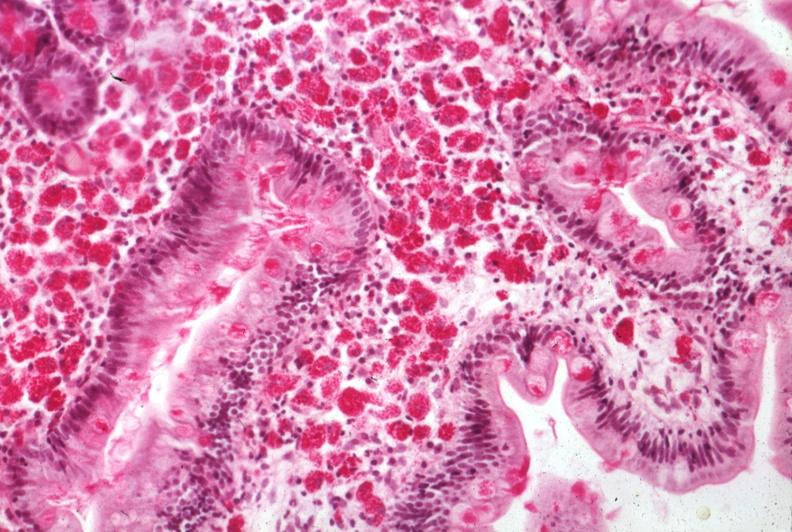what is present?
Answer the question using a single word or phrase. Gastrointestinal 